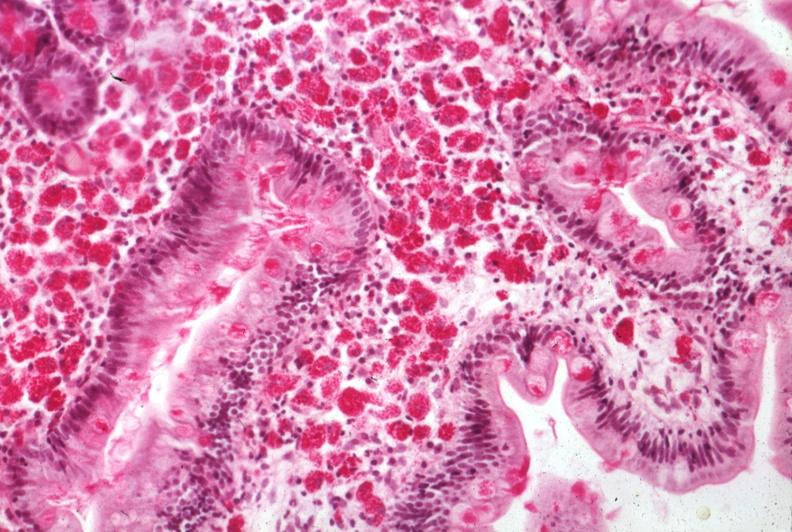what is present?
Answer the question using a single word or phrase. Gastrointestinal 